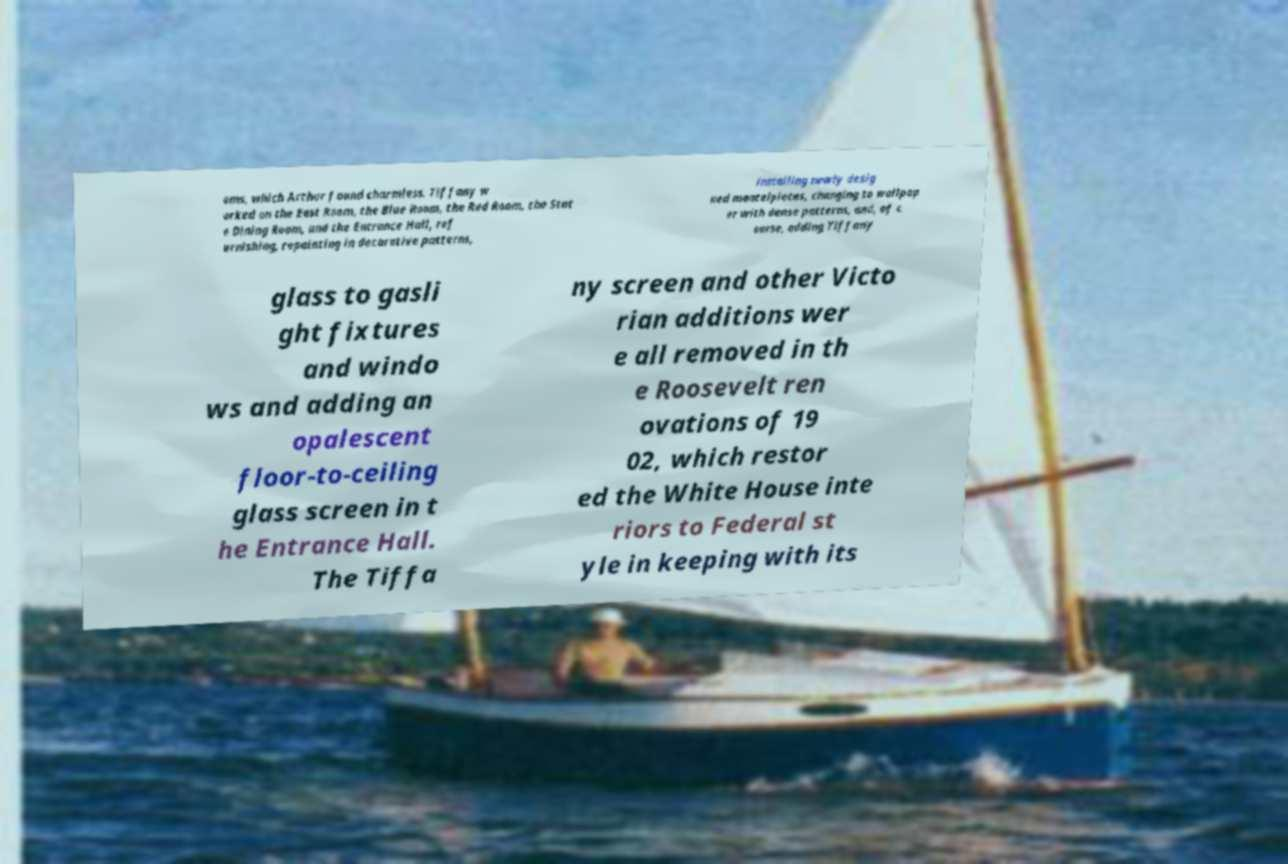For documentation purposes, I need the text within this image transcribed. Could you provide that? oms, which Arthur found charmless. Tiffany w orked on the East Room, the Blue Room, the Red Room, the Stat e Dining Room, and the Entrance Hall, ref urnishing, repainting in decorative patterns, installing newly desig ned mantelpieces, changing to wallpap er with dense patterns, and, of c ourse, adding Tiffany glass to gasli ght fixtures and windo ws and adding an opalescent floor-to-ceiling glass screen in t he Entrance Hall. The Tiffa ny screen and other Victo rian additions wer e all removed in th e Roosevelt ren ovations of 19 02, which restor ed the White House inte riors to Federal st yle in keeping with its 